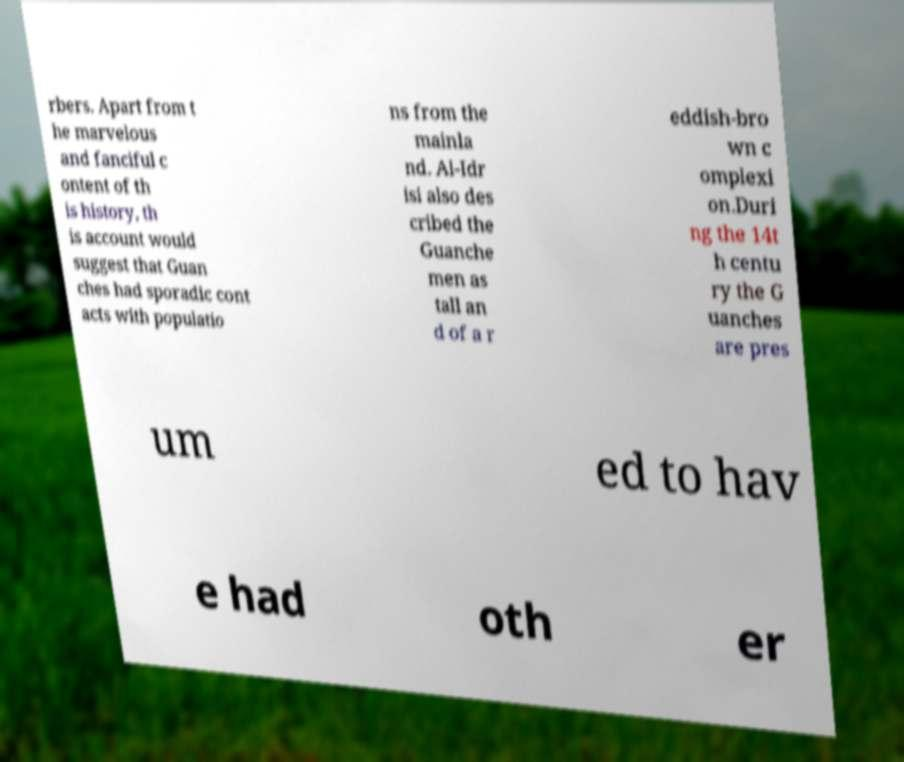Can you read and provide the text displayed in the image?This photo seems to have some interesting text. Can you extract and type it out for me? rbers. Apart from t he marvelous and fanciful c ontent of th is history, th is account would suggest that Guan ches had sporadic cont acts with populatio ns from the mainla nd. Al-Idr isi also des cribed the Guanche men as tall an d of a r eddish-bro wn c omplexi on.Duri ng the 14t h centu ry the G uanches are pres um ed to hav e had oth er 